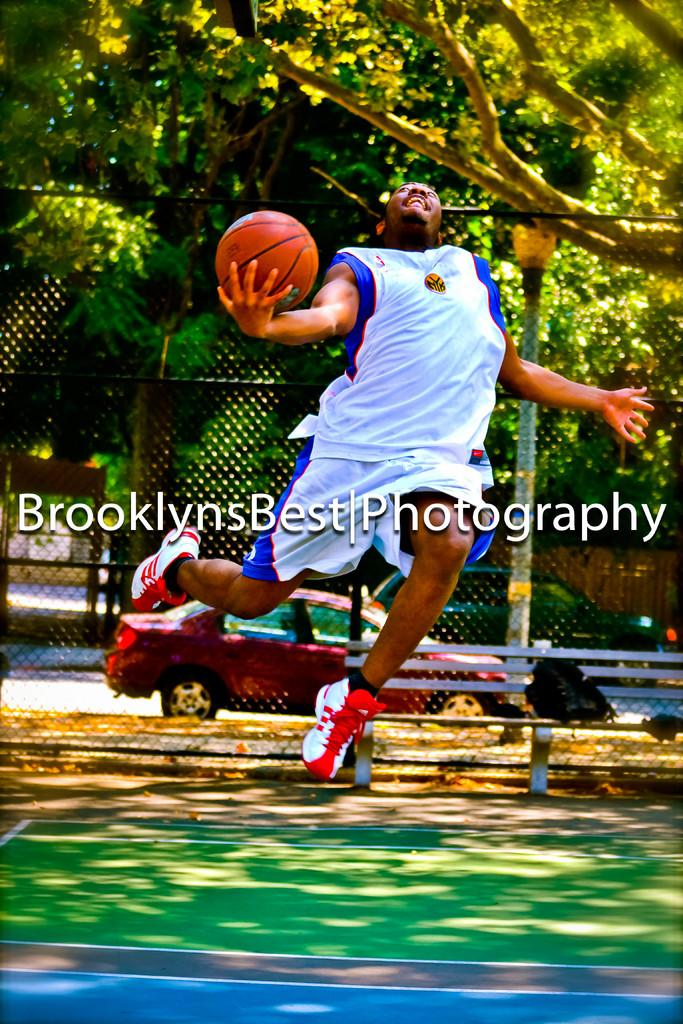What is the main subject of the image? There is a person in the image. What is the person doing in the image? The person is jumping and holding a ball. What can be seen in the background of the image? There is a car, a wire fence, trees, and a bench in the background of the image. Is there any text or marking on the image? Yes, the image has a watermark. What type of selection process is being conducted in the image? There is no indication of a selection process in the image; it features a person jumping and holding a ball. How many balls are visible in the image? There is only one ball visible in the image, as the person is holding it while jumping. 